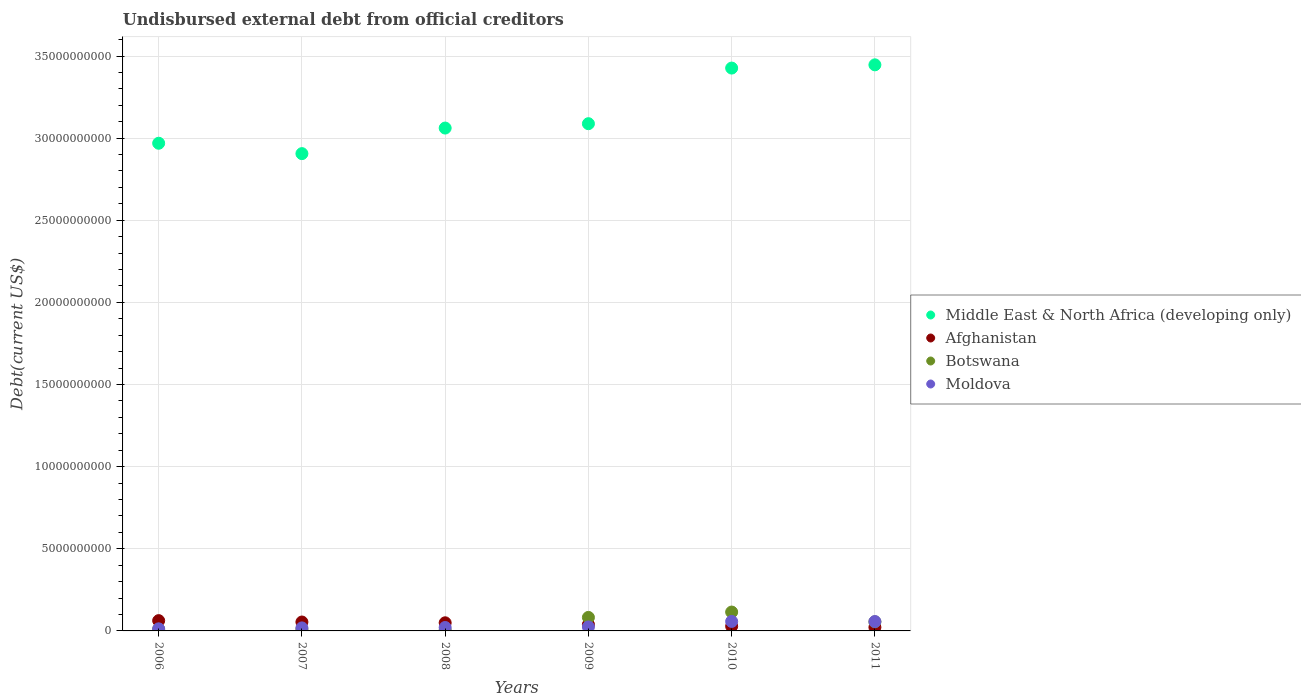How many different coloured dotlines are there?
Make the answer very short. 4. Is the number of dotlines equal to the number of legend labels?
Provide a short and direct response. Yes. What is the total debt in Middle East & North Africa (developing only) in 2008?
Keep it short and to the point. 3.06e+1. Across all years, what is the maximum total debt in Botswana?
Provide a short and direct response. 1.15e+09. Across all years, what is the minimum total debt in Afghanistan?
Provide a short and direct response. 2.20e+08. In which year was the total debt in Botswana maximum?
Provide a succinct answer. 2010. In which year was the total debt in Afghanistan minimum?
Provide a short and direct response. 2011. What is the total total debt in Middle East & North Africa (developing only) in the graph?
Offer a very short reply. 1.89e+11. What is the difference between the total debt in Botswana in 2009 and that in 2011?
Ensure brevity in your answer.  2.70e+08. What is the difference between the total debt in Moldova in 2006 and the total debt in Afghanistan in 2009?
Offer a terse response. -2.62e+08. What is the average total debt in Afghanistan per year?
Provide a short and direct response. 4.26e+08. In the year 2010, what is the difference between the total debt in Afghanistan and total debt in Botswana?
Keep it short and to the point. -8.64e+08. In how many years, is the total debt in Moldova greater than 6000000000 US$?
Your answer should be very brief. 0. What is the ratio of the total debt in Middle East & North Africa (developing only) in 2008 to that in 2011?
Keep it short and to the point. 0.89. Is the difference between the total debt in Afghanistan in 2008 and 2011 greater than the difference between the total debt in Botswana in 2008 and 2011?
Ensure brevity in your answer.  Yes. What is the difference between the highest and the second highest total debt in Afghanistan?
Provide a short and direct response. 8.39e+07. What is the difference between the highest and the lowest total debt in Moldova?
Offer a very short reply. 4.52e+08. In how many years, is the total debt in Botswana greater than the average total debt in Botswana taken over all years?
Give a very brief answer. 3. Is it the case that in every year, the sum of the total debt in Moldova and total debt in Botswana  is greater than the total debt in Middle East & North Africa (developing only)?
Keep it short and to the point. No. Does the graph contain grids?
Provide a short and direct response. Yes. How many legend labels are there?
Ensure brevity in your answer.  4. What is the title of the graph?
Give a very brief answer. Undisbursed external debt from official creditors. What is the label or title of the Y-axis?
Provide a short and direct response. Debt(current US$). What is the Debt(current US$) of Middle East & North Africa (developing only) in 2006?
Make the answer very short. 2.97e+1. What is the Debt(current US$) in Afghanistan in 2006?
Keep it short and to the point. 6.26e+08. What is the Debt(current US$) of Botswana in 2006?
Your answer should be very brief. 1.03e+08. What is the Debt(current US$) of Moldova in 2006?
Your answer should be compact. 1.26e+08. What is the Debt(current US$) in Middle East & North Africa (developing only) in 2007?
Your answer should be very brief. 2.91e+1. What is the Debt(current US$) in Afghanistan in 2007?
Give a very brief answer. 5.42e+08. What is the Debt(current US$) of Botswana in 2007?
Your answer should be compact. 1.04e+08. What is the Debt(current US$) of Moldova in 2007?
Offer a very short reply. 1.84e+08. What is the Debt(current US$) of Middle East & North Africa (developing only) in 2008?
Provide a succinct answer. 3.06e+1. What is the Debt(current US$) in Afghanistan in 2008?
Your answer should be compact. 4.95e+08. What is the Debt(current US$) in Botswana in 2008?
Your answer should be very brief. 5.04e+07. What is the Debt(current US$) in Moldova in 2008?
Give a very brief answer. 2.09e+08. What is the Debt(current US$) in Middle East & North Africa (developing only) in 2009?
Provide a succinct answer. 3.09e+1. What is the Debt(current US$) of Afghanistan in 2009?
Make the answer very short. 3.88e+08. What is the Debt(current US$) in Botswana in 2009?
Your answer should be very brief. 8.23e+08. What is the Debt(current US$) in Moldova in 2009?
Your response must be concise. 2.42e+08. What is the Debt(current US$) in Middle East & North Africa (developing only) in 2010?
Offer a very short reply. 3.43e+1. What is the Debt(current US$) in Afghanistan in 2010?
Your response must be concise. 2.84e+08. What is the Debt(current US$) in Botswana in 2010?
Offer a terse response. 1.15e+09. What is the Debt(current US$) in Moldova in 2010?
Offer a very short reply. 5.78e+08. What is the Debt(current US$) of Middle East & North Africa (developing only) in 2011?
Ensure brevity in your answer.  3.45e+1. What is the Debt(current US$) in Afghanistan in 2011?
Your answer should be compact. 2.20e+08. What is the Debt(current US$) in Botswana in 2011?
Your answer should be very brief. 5.53e+08. What is the Debt(current US$) of Moldova in 2011?
Keep it short and to the point. 5.70e+08. Across all years, what is the maximum Debt(current US$) in Middle East & North Africa (developing only)?
Give a very brief answer. 3.45e+1. Across all years, what is the maximum Debt(current US$) of Afghanistan?
Give a very brief answer. 6.26e+08. Across all years, what is the maximum Debt(current US$) of Botswana?
Keep it short and to the point. 1.15e+09. Across all years, what is the maximum Debt(current US$) of Moldova?
Give a very brief answer. 5.78e+08. Across all years, what is the minimum Debt(current US$) of Middle East & North Africa (developing only)?
Offer a terse response. 2.91e+1. Across all years, what is the minimum Debt(current US$) of Afghanistan?
Your answer should be compact. 2.20e+08. Across all years, what is the minimum Debt(current US$) in Botswana?
Offer a very short reply. 5.04e+07. Across all years, what is the minimum Debt(current US$) in Moldova?
Keep it short and to the point. 1.26e+08. What is the total Debt(current US$) in Middle East & North Africa (developing only) in the graph?
Offer a very short reply. 1.89e+11. What is the total Debt(current US$) in Afghanistan in the graph?
Make the answer very short. 2.56e+09. What is the total Debt(current US$) of Botswana in the graph?
Make the answer very short. 2.78e+09. What is the total Debt(current US$) of Moldova in the graph?
Your response must be concise. 1.91e+09. What is the difference between the Debt(current US$) of Middle East & North Africa (developing only) in 2006 and that in 2007?
Provide a short and direct response. 6.32e+08. What is the difference between the Debt(current US$) in Afghanistan in 2006 and that in 2007?
Provide a succinct answer. 8.39e+07. What is the difference between the Debt(current US$) of Botswana in 2006 and that in 2007?
Make the answer very short. -8.49e+05. What is the difference between the Debt(current US$) of Moldova in 2006 and that in 2007?
Make the answer very short. -5.74e+07. What is the difference between the Debt(current US$) of Middle East & North Africa (developing only) in 2006 and that in 2008?
Provide a short and direct response. -9.25e+08. What is the difference between the Debt(current US$) in Afghanistan in 2006 and that in 2008?
Make the answer very short. 1.32e+08. What is the difference between the Debt(current US$) of Botswana in 2006 and that in 2008?
Offer a terse response. 5.24e+07. What is the difference between the Debt(current US$) in Moldova in 2006 and that in 2008?
Give a very brief answer. -8.30e+07. What is the difference between the Debt(current US$) of Middle East & North Africa (developing only) in 2006 and that in 2009?
Your answer should be compact. -1.19e+09. What is the difference between the Debt(current US$) in Afghanistan in 2006 and that in 2009?
Your answer should be very brief. 2.38e+08. What is the difference between the Debt(current US$) of Botswana in 2006 and that in 2009?
Make the answer very short. -7.20e+08. What is the difference between the Debt(current US$) of Moldova in 2006 and that in 2009?
Provide a succinct answer. -1.16e+08. What is the difference between the Debt(current US$) in Middle East & North Africa (developing only) in 2006 and that in 2010?
Your response must be concise. -4.58e+09. What is the difference between the Debt(current US$) in Afghanistan in 2006 and that in 2010?
Make the answer very short. 3.42e+08. What is the difference between the Debt(current US$) of Botswana in 2006 and that in 2010?
Make the answer very short. -1.05e+09. What is the difference between the Debt(current US$) of Moldova in 2006 and that in 2010?
Make the answer very short. -4.52e+08. What is the difference between the Debt(current US$) of Middle East & North Africa (developing only) in 2006 and that in 2011?
Your response must be concise. -4.77e+09. What is the difference between the Debt(current US$) of Afghanistan in 2006 and that in 2011?
Offer a terse response. 4.06e+08. What is the difference between the Debt(current US$) of Botswana in 2006 and that in 2011?
Offer a very short reply. -4.50e+08. What is the difference between the Debt(current US$) in Moldova in 2006 and that in 2011?
Offer a very short reply. -4.44e+08. What is the difference between the Debt(current US$) of Middle East & North Africa (developing only) in 2007 and that in 2008?
Offer a terse response. -1.56e+09. What is the difference between the Debt(current US$) in Afghanistan in 2007 and that in 2008?
Offer a terse response. 4.77e+07. What is the difference between the Debt(current US$) in Botswana in 2007 and that in 2008?
Your response must be concise. 5.33e+07. What is the difference between the Debt(current US$) in Moldova in 2007 and that in 2008?
Your response must be concise. -2.56e+07. What is the difference between the Debt(current US$) of Middle East & North Africa (developing only) in 2007 and that in 2009?
Your answer should be very brief. -1.82e+09. What is the difference between the Debt(current US$) of Afghanistan in 2007 and that in 2009?
Your response must be concise. 1.54e+08. What is the difference between the Debt(current US$) of Botswana in 2007 and that in 2009?
Your answer should be compact. -7.19e+08. What is the difference between the Debt(current US$) in Moldova in 2007 and that in 2009?
Provide a succinct answer. -5.87e+07. What is the difference between the Debt(current US$) of Middle East & North Africa (developing only) in 2007 and that in 2010?
Give a very brief answer. -5.21e+09. What is the difference between the Debt(current US$) of Afghanistan in 2007 and that in 2010?
Provide a succinct answer. 2.58e+08. What is the difference between the Debt(current US$) in Botswana in 2007 and that in 2010?
Keep it short and to the point. -1.05e+09. What is the difference between the Debt(current US$) of Moldova in 2007 and that in 2010?
Your answer should be compact. -3.94e+08. What is the difference between the Debt(current US$) of Middle East & North Africa (developing only) in 2007 and that in 2011?
Ensure brevity in your answer.  -5.41e+09. What is the difference between the Debt(current US$) in Afghanistan in 2007 and that in 2011?
Your answer should be very brief. 3.22e+08. What is the difference between the Debt(current US$) in Botswana in 2007 and that in 2011?
Offer a terse response. -4.49e+08. What is the difference between the Debt(current US$) in Moldova in 2007 and that in 2011?
Your answer should be very brief. -3.86e+08. What is the difference between the Debt(current US$) in Middle East & North Africa (developing only) in 2008 and that in 2009?
Ensure brevity in your answer.  -2.65e+08. What is the difference between the Debt(current US$) in Afghanistan in 2008 and that in 2009?
Provide a short and direct response. 1.06e+08. What is the difference between the Debt(current US$) of Botswana in 2008 and that in 2009?
Offer a very short reply. -7.72e+08. What is the difference between the Debt(current US$) of Moldova in 2008 and that in 2009?
Keep it short and to the point. -3.31e+07. What is the difference between the Debt(current US$) in Middle East & North Africa (developing only) in 2008 and that in 2010?
Your answer should be very brief. -3.65e+09. What is the difference between the Debt(current US$) in Afghanistan in 2008 and that in 2010?
Provide a succinct answer. 2.10e+08. What is the difference between the Debt(current US$) in Botswana in 2008 and that in 2010?
Provide a succinct answer. -1.10e+09. What is the difference between the Debt(current US$) in Moldova in 2008 and that in 2010?
Offer a very short reply. -3.69e+08. What is the difference between the Debt(current US$) in Middle East & North Africa (developing only) in 2008 and that in 2011?
Ensure brevity in your answer.  -3.85e+09. What is the difference between the Debt(current US$) in Afghanistan in 2008 and that in 2011?
Make the answer very short. 2.75e+08. What is the difference between the Debt(current US$) in Botswana in 2008 and that in 2011?
Keep it short and to the point. -5.02e+08. What is the difference between the Debt(current US$) in Moldova in 2008 and that in 2011?
Ensure brevity in your answer.  -3.61e+08. What is the difference between the Debt(current US$) of Middle East & North Africa (developing only) in 2009 and that in 2010?
Give a very brief answer. -3.39e+09. What is the difference between the Debt(current US$) of Afghanistan in 2009 and that in 2010?
Make the answer very short. 1.04e+08. What is the difference between the Debt(current US$) in Botswana in 2009 and that in 2010?
Make the answer very short. -3.26e+08. What is the difference between the Debt(current US$) in Moldova in 2009 and that in 2010?
Provide a short and direct response. -3.36e+08. What is the difference between the Debt(current US$) in Middle East & North Africa (developing only) in 2009 and that in 2011?
Give a very brief answer. -3.58e+09. What is the difference between the Debt(current US$) in Afghanistan in 2009 and that in 2011?
Provide a short and direct response. 1.68e+08. What is the difference between the Debt(current US$) of Botswana in 2009 and that in 2011?
Give a very brief answer. 2.70e+08. What is the difference between the Debt(current US$) in Moldova in 2009 and that in 2011?
Provide a short and direct response. -3.27e+08. What is the difference between the Debt(current US$) of Middle East & North Africa (developing only) in 2010 and that in 2011?
Provide a short and direct response. -1.97e+08. What is the difference between the Debt(current US$) in Afghanistan in 2010 and that in 2011?
Your answer should be compact. 6.44e+07. What is the difference between the Debt(current US$) of Botswana in 2010 and that in 2011?
Make the answer very short. 5.96e+08. What is the difference between the Debt(current US$) of Moldova in 2010 and that in 2011?
Your answer should be very brief. 8.13e+06. What is the difference between the Debt(current US$) of Middle East & North Africa (developing only) in 2006 and the Debt(current US$) of Afghanistan in 2007?
Your response must be concise. 2.91e+1. What is the difference between the Debt(current US$) of Middle East & North Africa (developing only) in 2006 and the Debt(current US$) of Botswana in 2007?
Keep it short and to the point. 2.96e+1. What is the difference between the Debt(current US$) in Middle East & North Africa (developing only) in 2006 and the Debt(current US$) in Moldova in 2007?
Ensure brevity in your answer.  2.95e+1. What is the difference between the Debt(current US$) of Afghanistan in 2006 and the Debt(current US$) of Botswana in 2007?
Provide a short and direct response. 5.22e+08. What is the difference between the Debt(current US$) of Afghanistan in 2006 and the Debt(current US$) of Moldova in 2007?
Provide a short and direct response. 4.42e+08. What is the difference between the Debt(current US$) in Botswana in 2006 and the Debt(current US$) in Moldova in 2007?
Provide a short and direct response. -8.10e+07. What is the difference between the Debt(current US$) of Middle East & North Africa (developing only) in 2006 and the Debt(current US$) of Afghanistan in 2008?
Offer a terse response. 2.92e+1. What is the difference between the Debt(current US$) in Middle East & North Africa (developing only) in 2006 and the Debt(current US$) in Botswana in 2008?
Give a very brief answer. 2.96e+1. What is the difference between the Debt(current US$) in Middle East & North Africa (developing only) in 2006 and the Debt(current US$) in Moldova in 2008?
Your answer should be compact. 2.95e+1. What is the difference between the Debt(current US$) of Afghanistan in 2006 and the Debt(current US$) of Botswana in 2008?
Offer a very short reply. 5.76e+08. What is the difference between the Debt(current US$) in Afghanistan in 2006 and the Debt(current US$) in Moldova in 2008?
Your response must be concise. 4.17e+08. What is the difference between the Debt(current US$) in Botswana in 2006 and the Debt(current US$) in Moldova in 2008?
Offer a very short reply. -1.07e+08. What is the difference between the Debt(current US$) of Middle East & North Africa (developing only) in 2006 and the Debt(current US$) of Afghanistan in 2009?
Keep it short and to the point. 2.93e+1. What is the difference between the Debt(current US$) of Middle East & North Africa (developing only) in 2006 and the Debt(current US$) of Botswana in 2009?
Offer a very short reply. 2.89e+1. What is the difference between the Debt(current US$) in Middle East & North Africa (developing only) in 2006 and the Debt(current US$) in Moldova in 2009?
Your response must be concise. 2.94e+1. What is the difference between the Debt(current US$) of Afghanistan in 2006 and the Debt(current US$) of Botswana in 2009?
Your response must be concise. -1.96e+08. What is the difference between the Debt(current US$) in Afghanistan in 2006 and the Debt(current US$) in Moldova in 2009?
Give a very brief answer. 3.84e+08. What is the difference between the Debt(current US$) in Botswana in 2006 and the Debt(current US$) in Moldova in 2009?
Keep it short and to the point. -1.40e+08. What is the difference between the Debt(current US$) in Middle East & North Africa (developing only) in 2006 and the Debt(current US$) in Afghanistan in 2010?
Provide a succinct answer. 2.94e+1. What is the difference between the Debt(current US$) in Middle East & North Africa (developing only) in 2006 and the Debt(current US$) in Botswana in 2010?
Ensure brevity in your answer.  2.85e+1. What is the difference between the Debt(current US$) of Middle East & North Africa (developing only) in 2006 and the Debt(current US$) of Moldova in 2010?
Offer a very short reply. 2.91e+1. What is the difference between the Debt(current US$) in Afghanistan in 2006 and the Debt(current US$) in Botswana in 2010?
Offer a very short reply. -5.23e+08. What is the difference between the Debt(current US$) in Afghanistan in 2006 and the Debt(current US$) in Moldova in 2010?
Your answer should be compact. 4.81e+07. What is the difference between the Debt(current US$) in Botswana in 2006 and the Debt(current US$) in Moldova in 2010?
Keep it short and to the point. -4.75e+08. What is the difference between the Debt(current US$) in Middle East & North Africa (developing only) in 2006 and the Debt(current US$) in Afghanistan in 2011?
Your response must be concise. 2.95e+1. What is the difference between the Debt(current US$) of Middle East & North Africa (developing only) in 2006 and the Debt(current US$) of Botswana in 2011?
Offer a terse response. 2.91e+1. What is the difference between the Debt(current US$) of Middle East & North Africa (developing only) in 2006 and the Debt(current US$) of Moldova in 2011?
Your answer should be compact. 2.91e+1. What is the difference between the Debt(current US$) of Afghanistan in 2006 and the Debt(current US$) of Botswana in 2011?
Your answer should be compact. 7.35e+07. What is the difference between the Debt(current US$) in Afghanistan in 2006 and the Debt(current US$) in Moldova in 2011?
Your answer should be compact. 5.62e+07. What is the difference between the Debt(current US$) of Botswana in 2006 and the Debt(current US$) of Moldova in 2011?
Your response must be concise. -4.67e+08. What is the difference between the Debt(current US$) in Middle East & North Africa (developing only) in 2007 and the Debt(current US$) in Afghanistan in 2008?
Offer a very short reply. 2.86e+1. What is the difference between the Debt(current US$) of Middle East & North Africa (developing only) in 2007 and the Debt(current US$) of Botswana in 2008?
Provide a succinct answer. 2.90e+1. What is the difference between the Debt(current US$) in Middle East & North Africa (developing only) in 2007 and the Debt(current US$) in Moldova in 2008?
Your answer should be compact. 2.88e+1. What is the difference between the Debt(current US$) in Afghanistan in 2007 and the Debt(current US$) in Botswana in 2008?
Ensure brevity in your answer.  4.92e+08. What is the difference between the Debt(current US$) of Afghanistan in 2007 and the Debt(current US$) of Moldova in 2008?
Provide a short and direct response. 3.33e+08. What is the difference between the Debt(current US$) of Botswana in 2007 and the Debt(current US$) of Moldova in 2008?
Offer a terse response. -1.06e+08. What is the difference between the Debt(current US$) in Middle East & North Africa (developing only) in 2007 and the Debt(current US$) in Afghanistan in 2009?
Offer a terse response. 2.87e+1. What is the difference between the Debt(current US$) of Middle East & North Africa (developing only) in 2007 and the Debt(current US$) of Botswana in 2009?
Your answer should be very brief. 2.82e+1. What is the difference between the Debt(current US$) in Middle East & North Africa (developing only) in 2007 and the Debt(current US$) in Moldova in 2009?
Offer a very short reply. 2.88e+1. What is the difference between the Debt(current US$) of Afghanistan in 2007 and the Debt(current US$) of Botswana in 2009?
Your response must be concise. -2.80e+08. What is the difference between the Debt(current US$) of Afghanistan in 2007 and the Debt(current US$) of Moldova in 2009?
Your answer should be very brief. 3.00e+08. What is the difference between the Debt(current US$) of Botswana in 2007 and the Debt(current US$) of Moldova in 2009?
Make the answer very short. -1.39e+08. What is the difference between the Debt(current US$) in Middle East & North Africa (developing only) in 2007 and the Debt(current US$) in Afghanistan in 2010?
Your answer should be very brief. 2.88e+1. What is the difference between the Debt(current US$) of Middle East & North Africa (developing only) in 2007 and the Debt(current US$) of Botswana in 2010?
Your answer should be compact. 2.79e+1. What is the difference between the Debt(current US$) in Middle East & North Africa (developing only) in 2007 and the Debt(current US$) in Moldova in 2010?
Provide a short and direct response. 2.85e+1. What is the difference between the Debt(current US$) in Afghanistan in 2007 and the Debt(current US$) in Botswana in 2010?
Your response must be concise. -6.06e+08. What is the difference between the Debt(current US$) of Afghanistan in 2007 and the Debt(current US$) of Moldova in 2010?
Your response must be concise. -3.58e+07. What is the difference between the Debt(current US$) in Botswana in 2007 and the Debt(current US$) in Moldova in 2010?
Make the answer very short. -4.74e+08. What is the difference between the Debt(current US$) of Middle East & North Africa (developing only) in 2007 and the Debt(current US$) of Afghanistan in 2011?
Your response must be concise. 2.88e+1. What is the difference between the Debt(current US$) of Middle East & North Africa (developing only) in 2007 and the Debt(current US$) of Botswana in 2011?
Make the answer very short. 2.85e+1. What is the difference between the Debt(current US$) in Middle East & North Africa (developing only) in 2007 and the Debt(current US$) in Moldova in 2011?
Provide a succinct answer. 2.85e+1. What is the difference between the Debt(current US$) of Afghanistan in 2007 and the Debt(current US$) of Botswana in 2011?
Offer a very short reply. -1.04e+07. What is the difference between the Debt(current US$) in Afghanistan in 2007 and the Debt(current US$) in Moldova in 2011?
Keep it short and to the point. -2.77e+07. What is the difference between the Debt(current US$) in Botswana in 2007 and the Debt(current US$) in Moldova in 2011?
Your answer should be compact. -4.66e+08. What is the difference between the Debt(current US$) in Middle East & North Africa (developing only) in 2008 and the Debt(current US$) in Afghanistan in 2009?
Make the answer very short. 3.02e+1. What is the difference between the Debt(current US$) of Middle East & North Africa (developing only) in 2008 and the Debt(current US$) of Botswana in 2009?
Ensure brevity in your answer.  2.98e+1. What is the difference between the Debt(current US$) in Middle East & North Africa (developing only) in 2008 and the Debt(current US$) in Moldova in 2009?
Your answer should be very brief. 3.04e+1. What is the difference between the Debt(current US$) in Afghanistan in 2008 and the Debt(current US$) in Botswana in 2009?
Ensure brevity in your answer.  -3.28e+08. What is the difference between the Debt(current US$) in Afghanistan in 2008 and the Debt(current US$) in Moldova in 2009?
Provide a short and direct response. 2.52e+08. What is the difference between the Debt(current US$) of Botswana in 2008 and the Debt(current US$) of Moldova in 2009?
Keep it short and to the point. -1.92e+08. What is the difference between the Debt(current US$) of Middle East & North Africa (developing only) in 2008 and the Debt(current US$) of Afghanistan in 2010?
Provide a succinct answer. 3.03e+1. What is the difference between the Debt(current US$) of Middle East & North Africa (developing only) in 2008 and the Debt(current US$) of Botswana in 2010?
Your answer should be very brief. 2.95e+1. What is the difference between the Debt(current US$) of Middle East & North Africa (developing only) in 2008 and the Debt(current US$) of Moldova in 2010?
Offer a terse response. 3.00e+1. What is the difference between the Debt(current US$) of Afghanistan in 2008 and the Debt(current US$) of Botswana in 2010?
Give a very brief answer. -6.54e+08. What is the difference between the Debt(current US$) in Afghanistan in 2008 and the Debt(current US$) in Moldova in 2010?
Your answer should be very brief. -8.35e+07. What is the difference between the Debt(current US$) of Botswana in 2008 and the Debt(current US$) of Moldova in 2010?
Keep it short and to the point. -5.28e+08. What is the difference between the Debt(current US$) in Middle East & North Africa (developing only) in 2008 and the Debt(current US$) in Afghanistan in 2011?
Offer a very short reply. 3.04e+1. What is the difference between the Debt(current US$) in Middle East & North Africa (developing only) in 2008 and the Debt(current US$) in Botswana in 2011?
Make the answer very short. 3.01e+1. What is the difference between the Debt(current US$) in Middle East & North Africa (developing only) in 2008 and the Debt(current US$) in Moldova in 2011?
Provide a succinct answer. 3.00e+1. What is the difference between the Debt(current US$) in Afghanistan in 2008 and the Debt(current US$) in Botswana in 2011?
Keep it short and to the point. -5.81e+07. What is the difference between the Debt(current US$) in Afghanistan in 2008 and the Debt(current US$) in Moldova in 2011?
Give a very brief answer. -7.54e+07. What is the difference between the Debt(current US$) of Botswana in 2008 and the Debt(current US$) of Moldova in 2011?
Provide a succinct answer. -5.20e+08. What is the difference between the Debt(current US$) in Middle East & North Africa (developing only) in 2009 and the Debt(current US$) in Afghanistan in 2010?
Provide a short and direct response. 3.06e+1. What is the difference between the Debt(current US$) of Middle East & North Africa (developing only) in 2009 and the Debt(current US$) of Botswana in 2010?
Keep it short and to the point. 2.97e+1. What is the difference between the Debt(current US$) of Middle East & North Africa (developing only) in 2009 and the Debt(current US$) of Moldova in 2010?
Your answer should be very brief. 3.03e+1. What is the difference between the Debt(current US$) in Afghanistan in 2009 and the Debt(current US$) in Botswana in 2010?
Provide a short and direct response. -7.60e+08. What is the difference between the Debt(current US$) in Afghanistan in 2009 and the Debt(current US$) in Moldova in 2010?
Your answer should be compact. -1.90e+08. What is the difference between the Debt(current US$) of Botswana in 2009 and the Debt(current US$) of Moldova in 2010?
Your answer should be compact. 2.45e+08. What is the difference between the Debt(current US$) in Middle East & North Africa (developing only) in 2009 and the Debt(current US$) in Afghanistan in 2011?
Ensure brevity in your answer.  3.07e+1. What is the difference between the Debt(current US$) in Middle East & North Africa (developing only) in 2009 and the Debt(current US$) in Botswana in 2011?
Make the answer very short. 3.03e+1. What is the difference between the Debt(current US$) of Middle East & North Africa (developing only) in 2009 and the Debt(current US$) of Moldova in 2011?
Offer a very short reply. 3.03e+1. What is the difference between the Debt(current US$) of Afghanistan in 2009 and the Debt(current US$) of Botswana in 2011?
Ensure brevity in your answer.  -1.64e+08. What is the difference between the Debt(current US$) in Afghanistan in 2009 and the Debt(current US$) in Moldova in 2011?
Your answer should be very brief. -1.82e+08. What is the difference between the Debt(current US$) of Botswana in 2009 and the Debt(current US$) of Moldova in 2011?
Make the answer very short. 2.53e+08. What is the difference between the Debt(current US$) of Middle East & North Africa (developing only) in 2010 and the Debt(current US$) of Afghanistan in 2011?
Make the answer very short. 3.40e+1. What is the difference between the Debt(current US$) in Middle East & North Africa (developing only) in 2010 and the Debt(current US$) in Botswana in 2011?
Offer a terse response. 3.37e+1. What is the difference between the Debt(current US$) of Middle East & North Africa (developing only) in 2010 and the Debt(current US$) of Moldova in 2011?
Provide a succinct answer. 3.37e+1. What is the difference between the Debt(current US$) of Afghanistan in 2010 and the Debt(current US$) of Botswana in 2011?
Make the answer very short. -2.68e+08. What is the difference between the Debt(current US$) in Afghanistan in 2010 and the Debt(current US$) in Moldova in 2011?
Make the answer very short. -2.86e+08. What is the difference between the Debt(current US$) in Botswana in 2010 and the Debt(current US$) in Moldova in 2011?
Keep it short and to the point. 5.79e+08. What is the average Debt(current US$) of Middle East & North Africa (developing only) per year?
Make the answer very short. 3.15e+1. What is the average Debt(current US$) in Afghanistan per year?
Your answer should be very brief. 4.26e+08. What is the average Debt(current US$) in Botswana per year?
Ensure brevity in your answer.  4.63e+08. What is the average Debt(current US$) of Moldova per year?
Offer a very short reply. 3.18e+08. In the year 2006, what is the difference between the Debt(current US$) in Middle East & North Africa (developing only) and Debt(current US$) in Afghanistan?
Your answer should be very brief. 2.91e+1. In the year 2006, what is the difference between the Debt(current US$) in Middle East & North Africa (developing only) and Debt(current US$) in Botswana?
Offer a very short reply. 2.96e+1. In the year 2006, what is the difference between the Debt(current US$) of Middle East & North Africa (developing only) and Debt(current US$) of Moldova?
Make the answer very short. 2.96e+1. In the year 2006, what is the difference between the Debt(current US$) of Afghanistan and Debt(current US$) of Botswana?
Your answer should be very brief. 5.23e+08. In the year 2006, what is the difference between the Debt(current US$) of Afghanistan and Debt(current US$) of Moldova?
Offer a terse response. 5.00e+08. In the year 2006, what is the difference between the Debt(current US$) of Botswana and Debt(current US$) of Moldova?
Keep it short and to the point. -2.35e+07. In the year 2007, what is the difference between the Debt(current US$) of Middle East & North Africa (developing only) and Debt(current US$) of Afghanistan?
Your answer should be compact. 2.85e+1. In the year 2007, what is the difference between the Debt(current US$) of Middle East & North Africa (developing only) and Debt(current US$) of Botswana?
Ensure brevity in your answer.  2.90e+1. In the year 2007, what is the difference between the Debt(current US$) in Middle East & North Africa (developing only) and Debt(current US$) in Moldova?
Offer a terse response. 2.89e+1. In the year 2007, what is the difference between the Debt(current US$) of Afghanistan and Debt(current US$) of Botswana?
Ensure brevity in your answer.  4.39e+08. In the year 2007, what is the difference between the Debt(current US$) of Afghanistan and Debt(current US$) of Moldova?
Keep it short and to the point. 3.58e+08. In the year 2007, what is the difference between the Debt(current US$) of Botswana and Debt(current US$) of Moldova?
Offer a terse response. -8.01e+07. In the year 2008, what is the difference between the Debt(current US$) of Middle East & North Africa (developing only) and Debt(current US$) of Afghanistan?
Make the answer very short. 3.01e+1. In the year 2008, what is the difference between the Debt(current US$) in Middle East & North Africa (developing only) and Debt(current US$) in Botswana?
Your answer should be compact. 3.06e+1. In the year 2008, what is the difference between the Debt(current US$) in Middle East & North Africa (developing only) and Debt(current US$) in Moldova?
Offer a terse response. 3.04e+1. In the year 2008, what is the difference between the Debt(current US$) in Afghanistan and Debt(current US$) in Botswana?
Provide a succinct answer. 4.44e+08. In the year 2008, what is the difference between the Debt(current US$) in Afghanistan and Debt(current US$) in Moldova?
Your response must be concise. 2.85e+08. In the year 2008, what is the difference between the Debt(current US$) of Botswana and Debt(current US$) of Moldova?
Give a very brief answer. -1.59e+08. In the year 2009, what is the difference between the Debt(current US$) in Middle East & North Africa (developing only) and Debt(current US$) in Afghanistan?
Ensure brevity in your answer.  3.05e+1. In the year 2009, what is the difference between the Debt(current US$) of Middle East & North Africa (developing only) and Debt(current US$) of Botswana?
Ensure brevity in your answer.  3.01e+1. In the year 2009, what is the difference between the Debt(current US$) of Middle East & North Africa (developing only) and Debt(current US$) of Moldova?
Provide a short and direct response. 3.06e+1. In the year 2009, what is the difference between the Debt(current US$) of Afghanistan and Debt(current US$) of Botswana?
Offer a terse response. -4.34e+08. In the year 2009, what is the difference between the Debt(current US$) in Afghanistan and Debt(current US$) in Moldova?
Make the answer very short. 1.46e+08. In the year 2009, what is the difference between the Debt(current US$) of Botswana and Debt(current US$) of Moldova?
Give a very brief answer. 5.80e+08. In the year 2010, what is the difference between the Debt(current US$) in Middle East & North Africa (developing only) and Debt(current US$) in Afghanistan?
Offer a very short reply. 3.40e+1. In the year 2010, what is the difference between the Debt(current US$) of Middle East & North Africa (developing only) and Debt(current US$) of Botswana?
Your answer should be compact. 3.31e+1. In the year 2010, what is the difference between the Debt(current US$) of Middle East & North Africa (developing only) and Debt(current US$) of Moldova?
Your answer should be compact. 3.37e+1. In the year 2010, what is the difference between the Debt(current US$) of Afghanistan and Debt(current US$) of Botswana?
Provide a short and direct response. -8.64e+08. In the year 2010, what is the difference between the Debt(current US$) in Afghanistan and Debt(current US$) in Moldova?
Keep it short and to the point. -2.94e+08. In the year 2010, what is the difference between the Debt(current US$) of Botswana and Debt(current US$) of Moldova?
Offer a terse response. 5.71e+08. In the year 2011, what is the difference between the Debt(current US$) of Middle East & North Africa (developing only) and Debt(current US$) of Afghanistan?
Give a very brief answer. 3.42e+1. In the year 2011, what is the difference between the Debt(current US$) of Middle East & North Africa (developing only) and Debt(current US$) of Botswana?
Your response must be concise. 3.39e+1. In the year 2011, what is the difference between the Debt(current US$) in Middle East & North Africa (developing only) and Debt(current US$) in Moldova?
Ensure brevity in your answer.  3.39e+1. In the year 2011, what is the difference between the Debt(current US$) of Afghanistan and Debt(current US$) of Botswana?
Your response must be concise. -3.33e+08. In the year 2011, what is the difference between the Debt(current US$) of Afghanistan and Debt(current US$) of Moldova?
Keep it short and to the point. -3.50e+08. In the year 2011, what is the difference between the Debt(current US$) in Botswana and Debt(current US$) in Moldova?
Your answer should be very brief. -1.73e+07. What is the ratio of the Debt(current US$) of Middle East & North Africa (developing only) in 2006 to that in 2007?
Your response must be concise. 1.02. What is the ratio of the Debt(current US$) in Afghanistan in 2006 to that in 2007?
Make the answer very short. 1.15. What is the ratio of the Debt(current US$) of Botswana in 2006 to that in 2007?
Offer a very short reply. 0.99. What is the ratio of the Debt(current US$) of Moldova in 2006 to that in 2007?
Make the answer very short. 0.69. What is the ratio of the Debt(current US$) of Middle East & North Africa (developing only) in 2006 to that in 2008?
Provide a succinct answer. 0.97. What is the ratio of the Debt(current US$) in Afghanistan in 2006 to that in 2008?
Make the answer very short. 1.27. What is the ratio of the Debt(current US$) in Botswana in 2006 to that in 2008?
Provide a short and direct response. 2.04. What is the ratio of the Debt(current US$) of Moldova in 2006 to that in 2008?
Offer a terse response. 0.6. What is the ratio of the Debt(current US$) in Middle East & North Africa (developing only) in 2006 to that in 2009?
Provide a short and direct response. 0.96. What is the ratio of the Debt(current US$) in Afghanistan in 2006 to that in 2009?
Ensure brevity in your answer.  1.61. What is the ratio of the Debt(current US$) in Moldova in 2006 to that in 2009?
Make the answer very short. 0.52. What is the ratio of the Debt(current US$) of Middle East & North Africa (developing only) in 2006 to that in 2010?
Your answer should be compact. 0.87. What is the ratio of the Debt(current US$) in Afghanistan in 2006 to that in 2010?
Make the answer very short. 2.2. What is the ratio of the Debt(current US$) of Botswana in 2006 to that in 2010?
Provide a succinct answer. 0.09. What is the ratio of the Debt(current US$) in Moldova in 2006 to that in 2010?
Keep it short and to the point. 0.22. What is the ratio of the Debt(current US$) of Middle East & North Africa (developing only) in 2006 to that in 2011?
Keep it short and to the point. 0.86. What is the ratio of the Debt(current US$) in Afghanistan in 2006 to that in 2011?
Your answer should be compact. 2.85. What is the ratio of the Debt(current US$) of Botswana in 2006 to that in 2011?
Your answer should be very brief. 0.19. What is the ratio of the Debt(current US$) of Moldova in 2006 to that in 2011?
Provide a succinct answer. 0.22. What is the ratio of the Debt(current US$) in Middle East & North Africa (developing only) in 2007 to that in 2008?
Offer a terse response. 0.95. What is the ratio of the Debt(current US$) of Afghanistan in 2007 to that in 2008?
Provide a short and direct response. 1.1. What is the ratio of the Debt(current US$) of Botswana in 2007 to that in 2008?
Keep it short and to the point. 2.06. What is the ratio of the Debt(current US$) of Moldova in 2007 to that in 2008?
Your answer should be compact. 0.88. What is the ratio of the Debt(current US$) of Middle East & North Africa (developing only) in 2007 to that in 2009?
Your answer should be compact. 0.94. What is the ratio of the Debt(current US$) in Afghanistan in 2007 to that in 2009?
Keep it short and to the point. 1.4. What is the ratio of the Debt(current US$) of Botswana in 2007 to that in 2009?
Ensure brevity in your answer.  0.13. What is the ratio of the Debt(current US$) in Moldova in 2007 to that in 2009?
Ensure brevity in your answer.  0.76. What is the ratio of the Debt(current US$) of Middle East & North Africa (developing only) in 2007 to that in 2010?
Provide a succinct answer. 0.85. What is the ratio of the Debt(current US$) of Afghanistan in 2007 to that in 2010?
Offer a very short reply. 1.91. What is the ratio of the Debt(current US$) of Botswana in 2007 to that in 2010?
Your answer should be very brief. 0.09. What is the ratio of the Debt(current US$) of Moldova in 2007 to that in 2010?
Your answer should be compact. 0.32. What is the ratio of the Debt(current US$) in Middle East & North Africa (developing only) in 2007 to that in 2011?
Keep it short and to the point. 0.84. What is the ratio of the Debt(current US$) of Afghanistan in 2007 to that in 2011?
Give a very brief answer. 2.46. What is the ratio of the Debt(current US$) in Botswana in 2007 to that in 2011?
Make the answer very short. 0.19. What is the ratio of the Debt(current US$) of Moldova in 2007 to that in 2011?
Provide a succinct answer. 0.32. What is the ratio of the Debt(current US$) of Middle East & North Africa (developing only) in 2008 to that in 2009?
Provide a succinct answer. 0.99. What is the ratio of the Debt(current US$) in Afghanistan in 2008 to that in 2009?
Ensure brevity in your answer.  1.27. What is the ratio of the Debt(current US$) of Botswana in 2008 to that in 2009?
Offer a terse response. 0.06. What is the ratio of the Debt(current US$) of Moldova in 2008 to that in 2009?
Provide a succinct answer. 0.86. What is the ratio of the Debt(current US$) of Middle East & North Africa (developing only) in 2008 to that in 2010?
Ensure brevity in your answer.  0.89. What is the ratio of the Debt(current US$) of Afghanistan in 2008 to that in 2010?
Keep it short and to the point. 1.74. What is the ratio of the Debt(current US$) in Botswana in 2008 to that in 2010?
Make the answer very short. 0.04. What is the ratio of the Debt(current US$) of Moldova in 2008 to that in 2010?
Provide a short and direct response. 0.36. What is the ratio of the Debt(current US$) of Middle East & North Africa (developing only) in 2008 to that in 2011?
Keep it short and to the point. 0.89. What is the ratio of the Debt(current US$) of Afghanistan in 2008 to that in 2011?
Provide a short and direct response. 2.25. What is the ratio of the Debt(current US$) in Botswana in 2008 to that in 2011?
Ensure brevity in your answer.  0.09. What is the ratio of the Debt(current US$) in Moldova in 2008 to that in 2011?
Your response must be concise. 0.37. What is the ratio of the Debt(current US$) in Middle East & North Africa (developing only) in 2009 to that in 2010?
Your response must be concise. 0.9. What is the ratio of the Debt(current US$) of Afghanistan in 2009 to that in 2010?
Keep it short and to the point. 1.37. What is the ratio of the Debt(current US$) of Botswana in 2009 to that in 2010?
Your answer should be very brief. 0.72. What is the ratio of the Debt(current US$) of Moldova in 2009 to that in 2010?
Provide a succinct answer. 0.42. What is the ratio of the Debt(current US$) in Middle East & North Africa (developing only) in 2009 to that in 2011?
Make the answer very short. 0.9. What is the ratio of the Debt(current US$) in Afghanistan in 2009 to that in 2011?
Offer a very short reply. 1.77. What is the ratio of the Debt(current US$) of Botswana in 2009 to that in 2011?
Provide a succinct answer. 1.49. What is the ratio of the Debt(current US$) of Moldova in 2009 to that in 2011?
Offer a terse response. 0.43. What is the ratio of the Debt(current US$) of Afghanistan in 2010 to that in 2011?
Give a very brief answer. 1.29. What is the ratio of the Debt(current US$) in Botswana in 2010 to that in 2011?
Your answer should be very brief. 2.08. What is the ratio of the Debt(current US$) in Moldova in 2010 to that in 2011?
Your response must be concise. 1.01. What is the difference between the highest and the second highest Debt(current US$) in Middle East & North Africa (developing only)?
Make the answer very short. 1.97e+08. What is the difference between the highest and the second highest Debt(current US$) in Afghanistan?
Your answer should be very brief. 8.39e+07. What is the difference between the highest and the second highest Debt(current US$) of Botswana?
Your response must be concise. 3.26e+08. What is the difference between the highest and the second highest Debt(current US$) in Moldova?
Make the answer very short. 8.13e+06. What is the difference between the highest and the lowest Debt(current US$) in Middle East & North Africa (developing only)?
Your answer should be compact. 5.41e+09. What is the difference between the highest and the lowest Debt(current US$) in Afghanistan?
Give a very brief answer. 4.06e+08. What is the difference between the highest and the lowest Debt(current US$) of Botswana?
Give a very brief answer. 1.10e+09. What is the difference between the highest and the lowest Debt(current US$) of Moldova?
Give a very brief answer. 4.52e+08. 